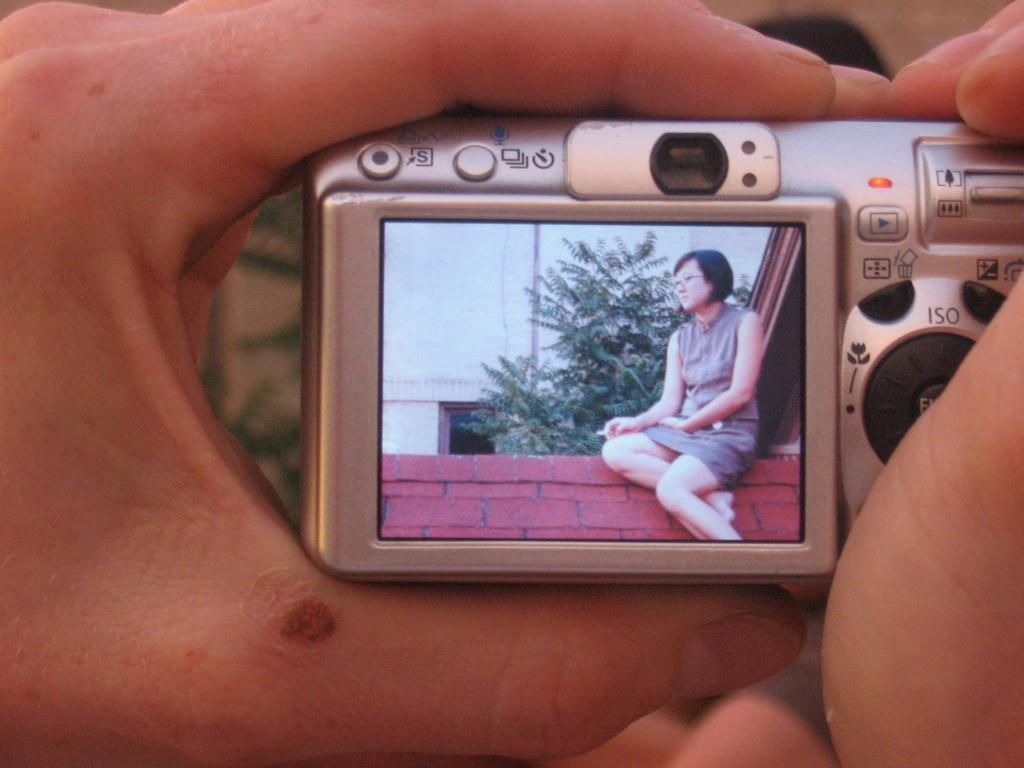<image>
Present a compact description of the photo's key features. A digital camera allows for adjustment of the ISO. 